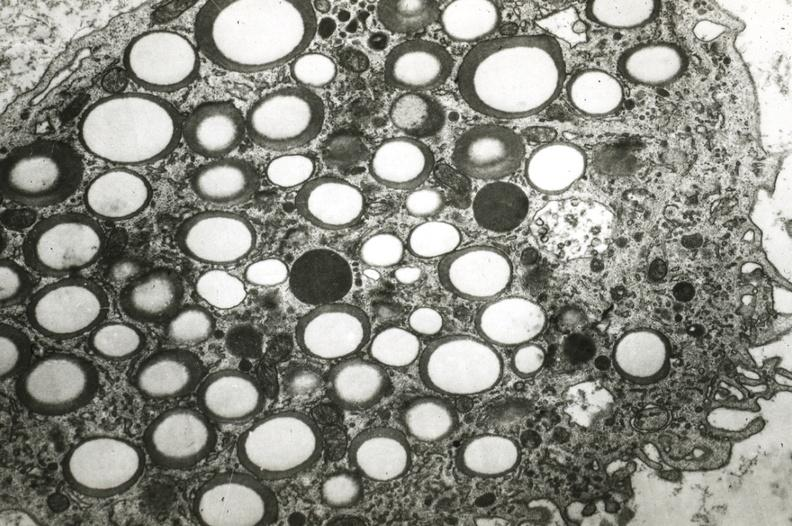what does this image show?
Answer the question using a single word or phrase. Foam cell 